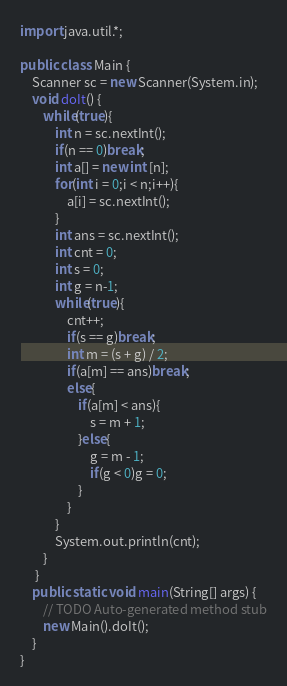Convert code to text. <code><loc_0><loc_0><loc_500><loc_500><_Java_>import java.util.*;

public class Main {
	Scanner sc = new Scanner(System.in);
	void doIt() {
		while(true){
			int n = sc.nextInt();
			if(n == 0)break;
			int a[] = new int [n];
			for(int i = 0;i < n;i++){
				a[i] = sc.nextInt();
			}
			int ans = sc.nextInt();
			int cnt = 0;
			int s = 0;
			int g = n-1;
			while(true){
				cnt++;
				if(s == g)break;
				int m = (s + g) / 2;
				if(a[m] == ans)break;
				else{
					if(a[m] < ans){
						s = m + 1;
					}else{
						g = m - 1;
						if(g < 0)g = 0;
					}
				}
			}
			System.out.println(cnt);
		}
     }
	public static void main(String[] args) {
    	// TODO Auto-generated method stub
    	new Main().doIt();
    }
}</code> 